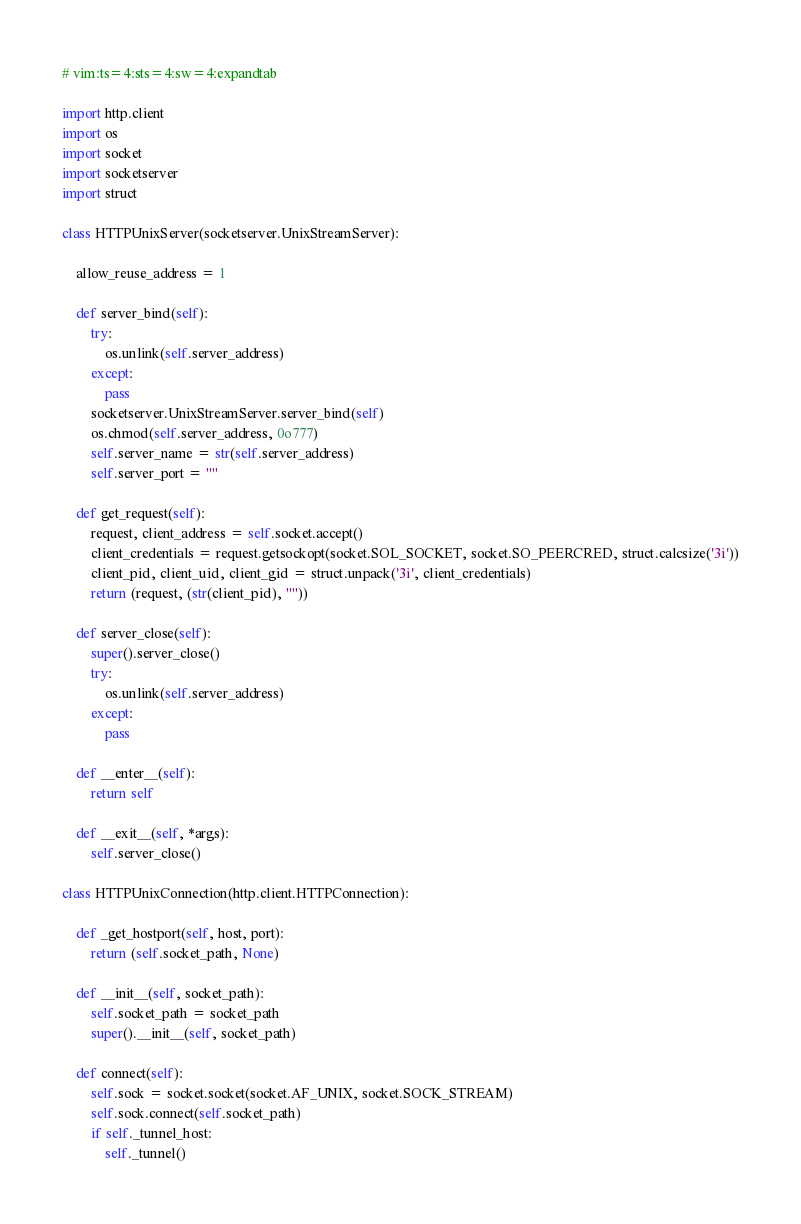<code> <loc_0><loc_0><loc_500><loc_500><_Python_># vim:ts=4:sts=4:sw=4:expandtab

import http.client
import os
import socket
import socketserver
import struct

class HTTPUnixServer(socketserver.UnixStreamServer):
    
    allow_reuse_address = 1
    
    def server_bind(self):
        try:
            os.unlink(self.server_address)
        except:
            pass
        socketserver.UnixStreamServer.server_bind(self)
        os.chmod(self.server_address, 0o777)
        self.server_name = str(self.server_address)
        self.server_port = ""

    def get_request(self):
        request, client_address = self.socket.accept()
        client_credentials = request.getsockopt(socket.SOL_SOCKET, socket.SO_PEERCRED, struct.calcsize('3i'))
        client_pid, client_uid, client_gid = struct.unpack('3i', client_credentials)
        return (request, (str(client_pid), ""))

    def server_close(self):
        super().server_close()
        try:
            os.unlink(self.server_address)
        except:
            pass

    def __enter__(self):
        return self

    def __exit__(self, *args):
        self.server_close()

class HTTPUnixConnection(http.client.HTTPConnection):

    def _get_hostport(self, host, port):
        return (self.socket_path, None)

    def __init__(self, socket_path):
        self.socket_path = socket_path
        super().__init__(self, socket_path)

    def connect(self):
        self.sock = socket.socket(socket.AF_UNIX, socket.SOCK_STREAM)
        self.sock.connect(self.socket_path)
        if self._tunnel_host:
            self._tunnel()
</code> 